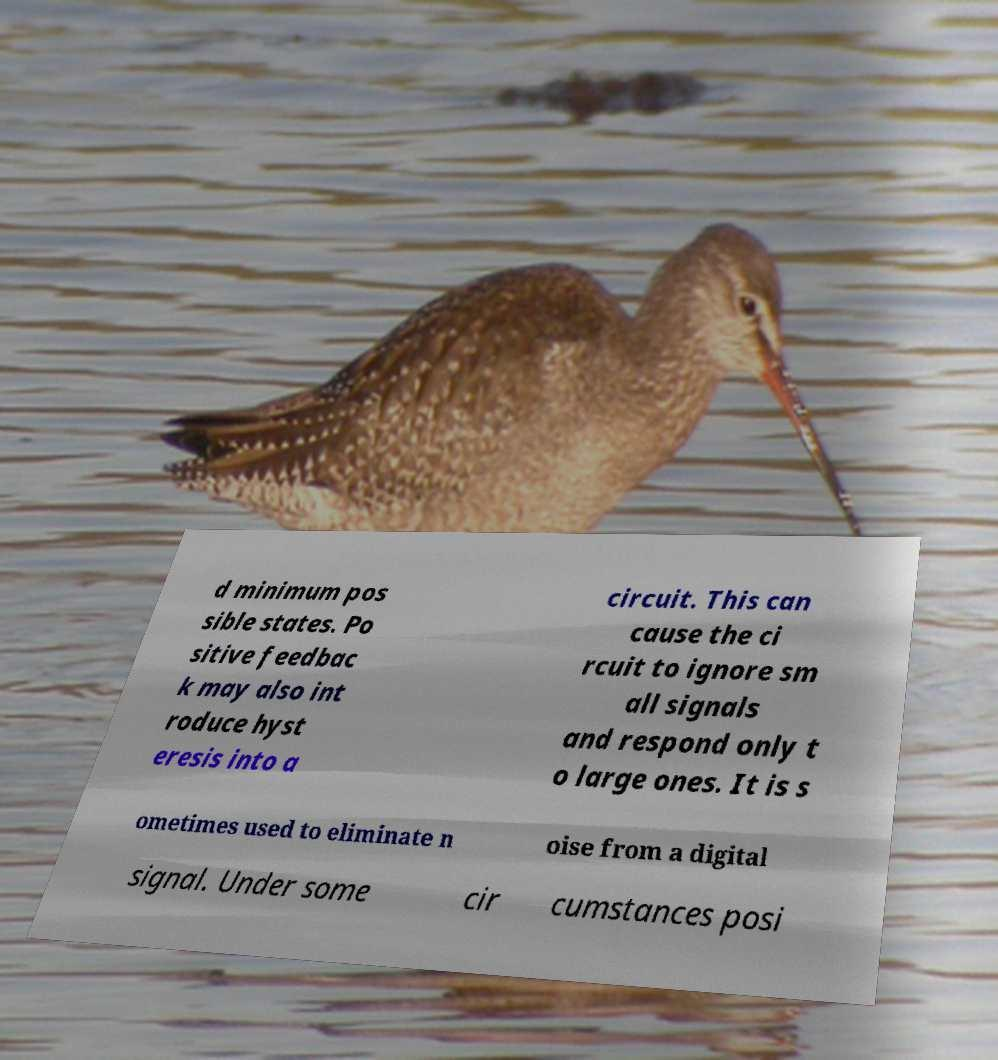Could you extract and type out the text from this image? d minimum pos sible states. Po sitive feedbac k may also int roduce hyst eresis into a circuit. This can cause the ci rcuit to ignore sm all signals and respond only t o large ones. It is s ometimes used to eliminate n oise from a digital signal. Under some cir cumstances posi 